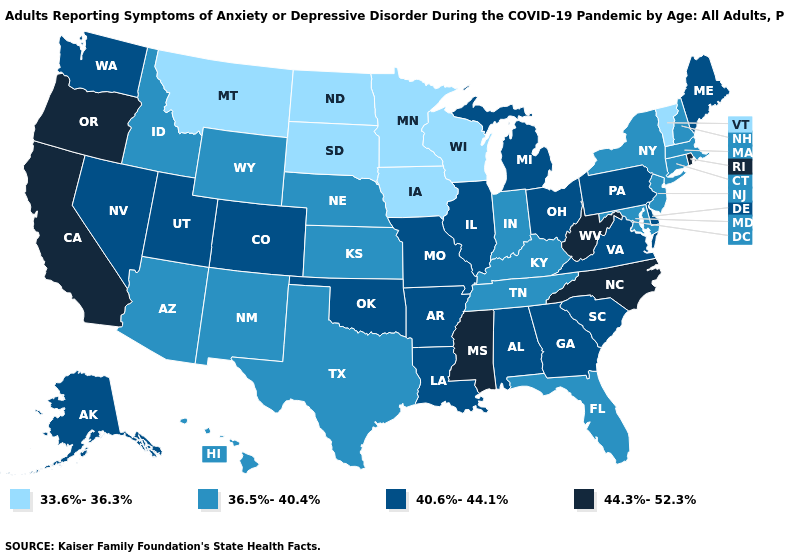Which states hav the highest value in the West?
Quick response, please. California, Oregon. Which states have the highest value in the USA?
Keep it brief. California, Mississippi, North Carolina, Oregon, Rhode Island, West Virginia. Does Louisiana have a higher value than Alaska?
Write a very short answer. No. Does West Virginia have the highest value in the USA?
Be succinct. Yes. Which states hav the highest value in the West?
Write a very short answer. California, Oregon. What is the value of New York?
Concise answer only. 36.5%-40.4%. Name the states that have a value in the range 44.3%-52.3%?
Concise answer only. California, Mississippi, North Carolina, Oregon, Rhode Island, West Virginia. Name the states that have a value in the range 33.6%-36.3%?
Concise answer only. Iowa, Minnesota, Montana, North Dakota, South Dakota, Vermont, Wisconsin. Does Hawaii have a higher value than Minnesota?
Answer briefly. Yes. Among the states that border North Dakota , which have the lowest value?
Short answer required. Minnesota, Montana, South Dakota. What is the lowest value in states that border Alabama?
Be succinct. 36.5%-40.4%. Does Vermont have the lowest value in the Northeast?
Write a very short answer. Yes. Name the states that have a value in the range 36.5%-40.4%?
Write a very short answer. Arizona, Connecticut, Florida, Hawaii, Idaho, Indiana, Kansas, Kentucky, Maryland, Massachusetts, Nebraska, New Hampshire, New Jersey, New Mexico, New York, Tennessee, Texas, Wyoming. Name the states that have a value in the range 36.5%-40.4%?
Answer briefly. Arizona, Connecticut, Florida, Hawaii, Idaho, Indiana, Kansas, Kentucky, Maryland, Massachusetts, Nebraska, New Hampshire, New Jersey, New Mexico, New York, Tennessee, Texas, Wyoming. What is the value of West Virginia?
Give a very brief answer. 44.3%-52.3%. 